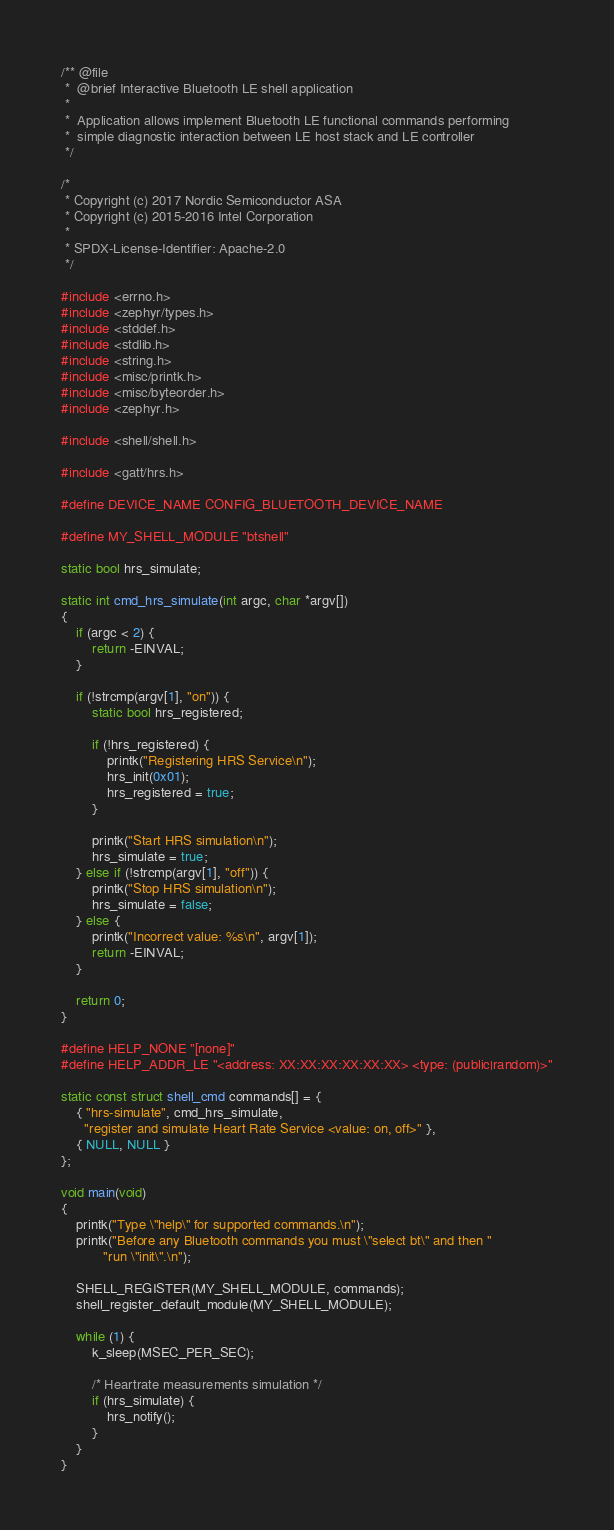<code> <loc_0><loc_0><loc_500><loc_500><_C_>/** @file
 *  @brief Interactive Bluetooth LE shell application
 *
 *  Application allows implement Bluetooth LE functional commands performing
 *  simple diagnostic interaction between LE host stack and LE controller
 */

/*
 * Copyright (c) 2017 Nordic Semiconductor ASA
 * Copyright (c) 2015-2016 Intel Corporation
 *
 * SPDX-License-Identifier: Apache-2.0
 */

#include <errno.h>
#include <zephyr/types.h>
#include <stddef.h>
#include <stdlib.h>
#include <string.h>
#include <misc/printk.h>
#include <misc/byteorder.h>
#include <zephyr.h>

#include <shell/shell.h>

#include <gatt/hrs.h>

#define DEVICE_NAME CONFIG_BLUETOOTH_DEVICE_NAME

#define MY_SHELL_MODULE "btshell"

static bool hrs_simulate;

static int cmd_hrs_simulate(int argc, char *argv[])
{
	if (argc < 2) {
		return -EINVAL;
	}

	if (!strcmp(argv[1], "on")) {
		static bool hrs_registered;

		if (!hrs_registered) {
			printk("Registering HRS Service\n");
			hrs_init(0x01);
			hrs_registered = true;
		}

		printk("Start HRS simulation\n");
		hrs_simulate = true;
	} else if (!strcmp(argv[1], "off")) {
		printk("Stop HRS simulation\n");
		hrs_simulate = false;
	} else {
		printk("Incorrect value: %s\n", argv[1]);
		return -EINVAL;
	}

	return 0;
}

#define HELP_NONE "[none]"
#define HELP_ADDR_LE "<address: XX:XX:XX:XX:XX:XX> <type: (public|random)>"

static const struct shell_cmd commands[] = {
	{ "hrs-simulate", cmd_hrs_simulate,
	  "register and simulate Heart Rate Service <value: on, off>" },
	{ NULL, NULL }
};

void main(void)
{
	printk("Type \"help\" for supported commands.\n");
	printk("Before any Bluetooth commands you must \"select bt\" and then "
	       "run \"init\".\n");

	SHELL_REGISTER(MY_SHELL_MODULE, commands);
	shell_register_default_module(MY_SHELL_MODULE);

	while (1) {
		k_sleep(MSEC_PER_SEC);

		/* Heartrate measurements simulation */
		if (hrs_simulate) {
			hrs_notify();
		}
	}
}
</code> 